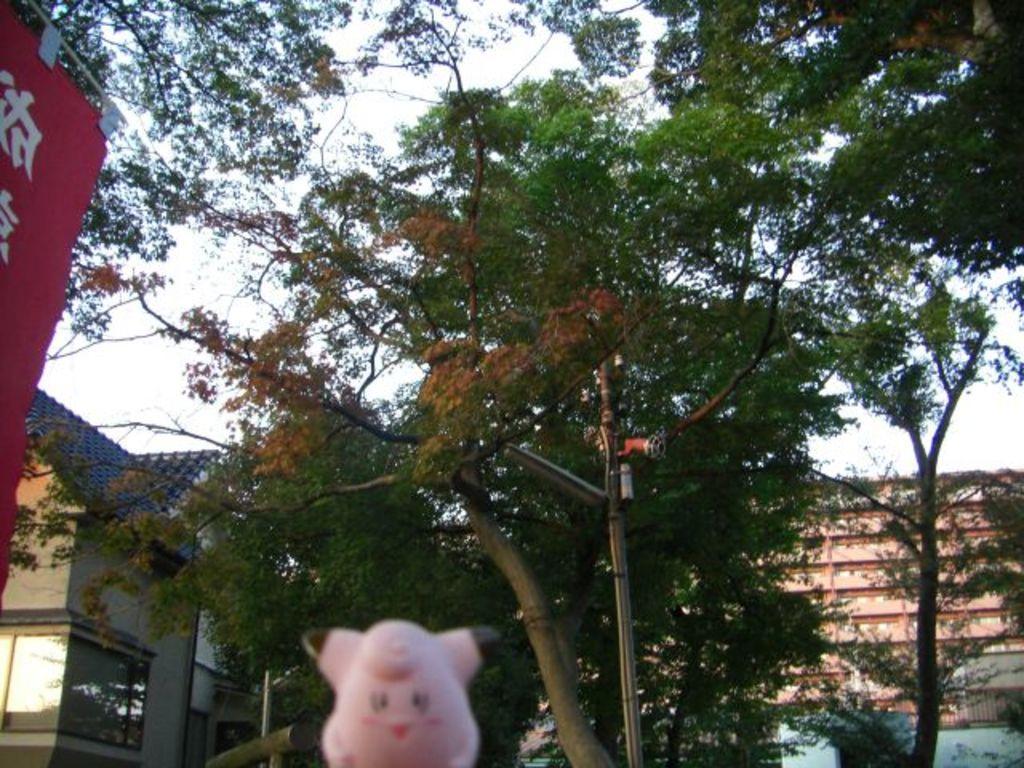Can you describe this image briefly? In this image I can see a pink colour toy in the front. In the background I can see few poles, a light, number of trees, few buildings and the sky. On the left side of this image I can see a red colour thing and on it I can see something is written. 